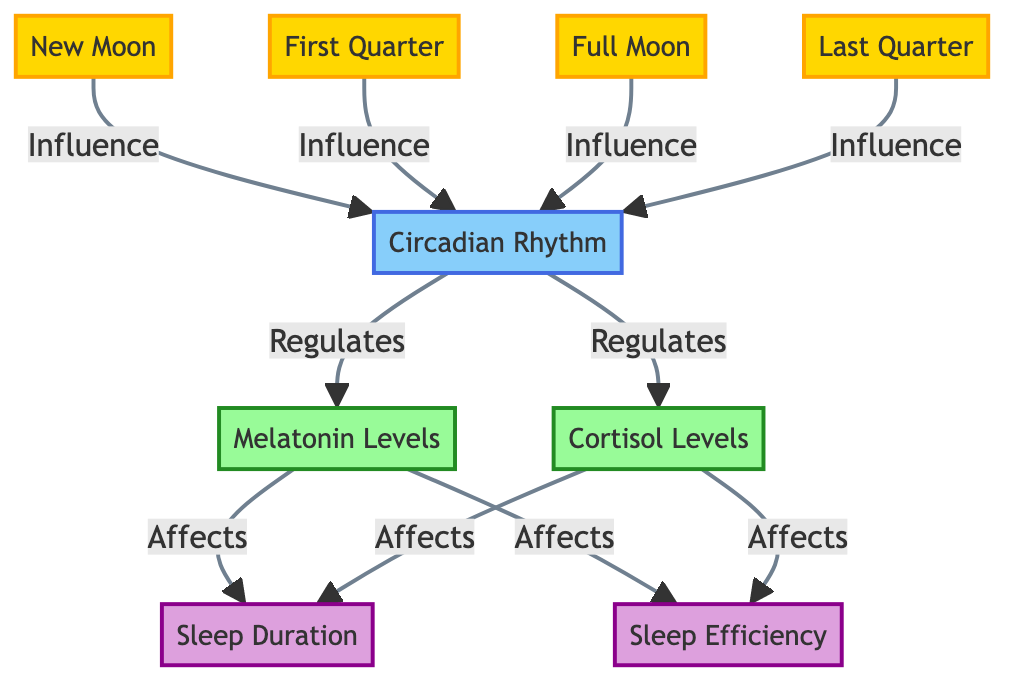What is the initial phase of the moon displayed in the diagram? The diagram shows the "New Moon" as the first node in the lunar phases, indicating the starting point in the lunar cycle each month.
Answer: New Moon How many lunar phases are represented in the diagram? Counting the distinct nodes for lunar phases (New Moon, First Quarter, Full Moon, Last Quarter), we see there are four lunar phases represented.
Answer: 4 What does the Circadian Rhythm regulate according to the diagram? The diagram shows that the Circadian Rhythm regulates Melatonin Levels and Cortisol Levels, which are both crucial hormones for sleep and wakefulness.
Answer: Melatonin Levels and Cortisol Levels Which lunar phase has the most significant influence on circadian rhythms according to the arrows in the diagram? All lunar phases (New Moon, First Quarter, Full Moon, Last Quarter) point to the Circadian Rhythm, indicating that they all have a significant influence; however, no individual phase is highlighted as having more influence than the others.
Answer: All lunar phases What hormone levels are affected by Melatonin Levels as shown in the diagram? The diagram indicates that Melatonin Levels affect both Sleep Duration and Sleep Efficiency, linking these hormones directly to sleep-related metrics.
Answer: Sleep Duration and Sleep Efficiency How do Cortisol Levels affect sleep metrics according to the diagram? The arrows show that Cortisol Levels influence both Sleep Duration and Sleep Efficiency, meaning both aspects of sleep are directly influenced by the levels of cortisol hormone.
Answer: Sleep Duration and Sleep Efficiency In the relationship between lunar phases and circadian rhythms, what is the role of the full moon? The Full Moon node in the diagram points to Circadian Rhythm, indicating that the Full Moon phase contributes to the regulation of circadian rhythms, similar to the other lunar phases.
Answer: Influence on Circadian Rhythm What color represents the Circadian Rhythm in the diagram? The Circadian Rhythm is represented by the color associated with the rhythm class, specifically in light blue (fill:#87CEFA), which distinguishes it from lunar phases and hormone levels.
Answer: Light blue Which hormone's levels are shown to be regulated by Circadian Rhythm according to the diagram? The Circadian Rhythm regulates both Melatonin Levels and Cortisol Levels, as indicated by the outgoing arrows from the Circadian Rhythm node.
Answer: Melatonin Levels and Cortisol Levels What is shown to affect Sleep Duration primarily in the diagram? The diagram indicates that both Melatonin Levels and Cortisol Levels affect Sleep Duration, linking hormonal levels to one of the key aspects of sleep.
Answer: Melatonin Levels and Cortisol Levels 